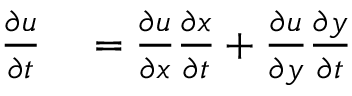<formula> <loc_0><loc_0><loc_500><loc_500>\begin{array} { r l } { { \frac { \partial u } { \partial t } } } & = { \frac { \partial u } { \partial x } } { \frac { \partial x } { \partial t } } + { \frac { \partial u } { \partial y } } { \frac { \partial y } { \partial t } } } \end{array}</formula> 